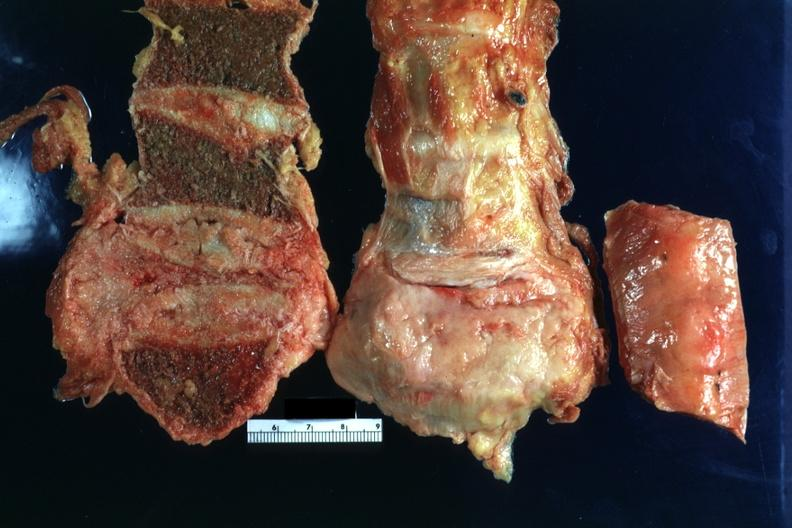what is present?
Answer the question using a single word or phrase. Joints 